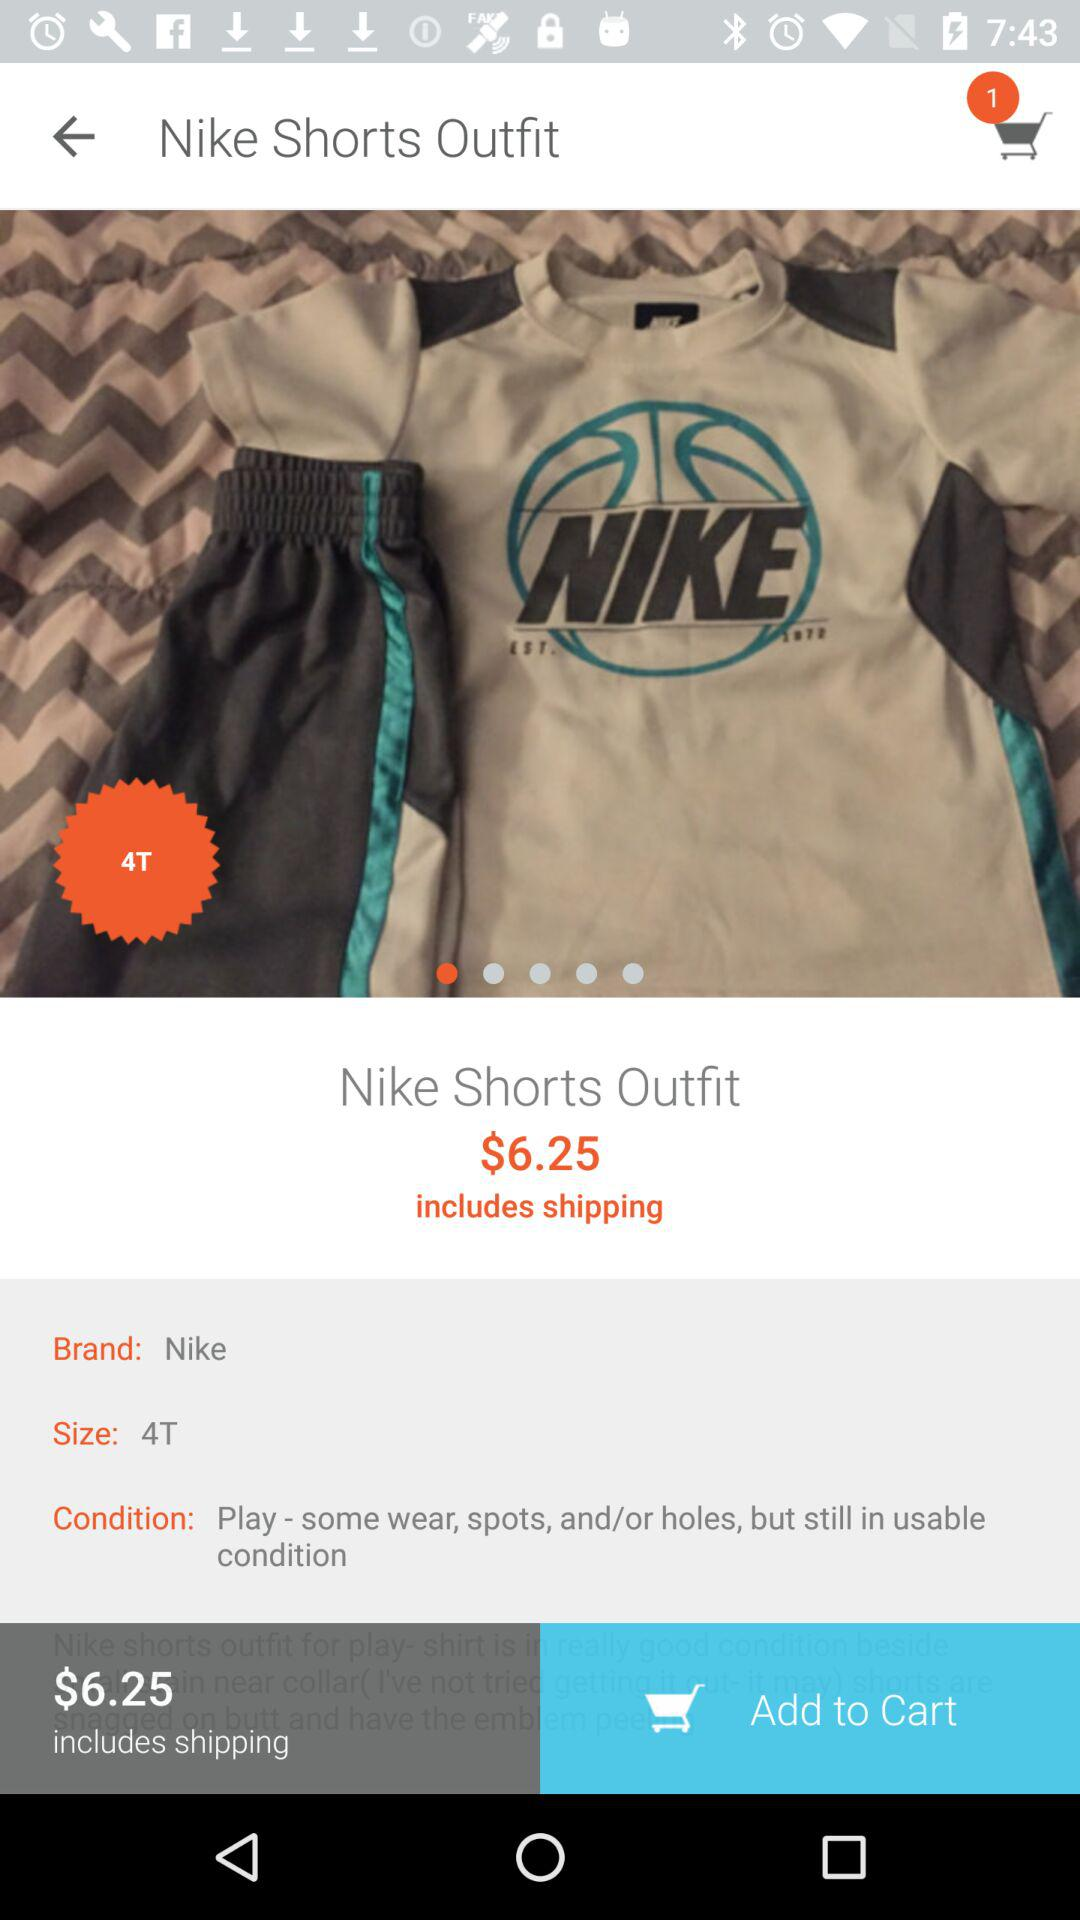How many items are added to the cart? There is 1 item added to the cart. 